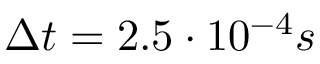Convert formula to latex. <formula><loc_0><loc_0><loc_500><loc_500>\Delta t = 2 . 5 \cdot 1 0 ^ { - 4 } s</formula> 